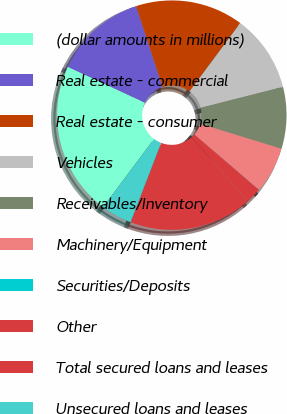Convert chart to OTSL. <chart><loc_0><loc_0><loc_500><loc_500><pie_chart><fcel>(dollar amounts in millions)<fcel>Real estate - commercial<fcel>Real estate - consumer<fcel>Vehicles<fcel>Receivables/Inventory<fcel>Machinery/Equipment<fcel>Securities/Deposits<fcel>Other<fcel>Total secured loans and leases<fcel>Unsecured loans and leases<nl><fcel>21.71%<fcel>13.04%<fcel>15.21%<fcel>10.87%<fcel>8.7%<fcel>6.53%<fcel>0.02%<fcel>2.19%<fcel>17.38%<fcel>4.36%<nl></chart> 